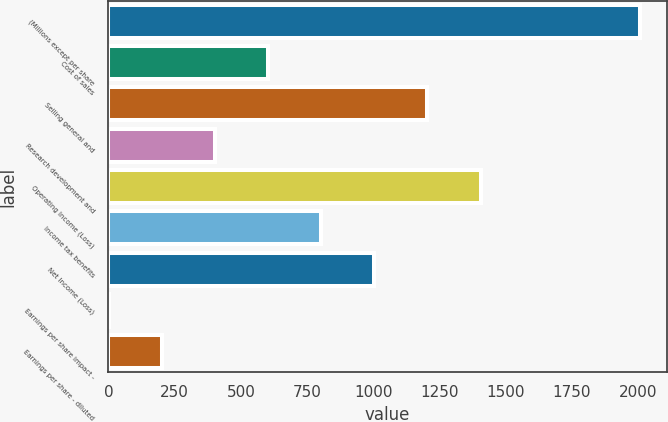<chart> <loc_0><loc_0><loc_500><loc_500><bar_chart><fcel>(Millions except per share<fcel>Cost of sales<fcel>Selling general and<fcel>Research development and<fcel>Operating Income (Loss)<fcel>Income tax benefits<fcel>Net Income (Loss)<fcel>Earnings per share impact -<fcel>Earnings per share - diluted<nl><fcel>2007<fcel>602.22<fcel>1204.26<fcel>401.54<fcel>1404.94<fcel>802.9<fcel>1003.58<fcel>0.18<fcel>200.86<nl></chart> 